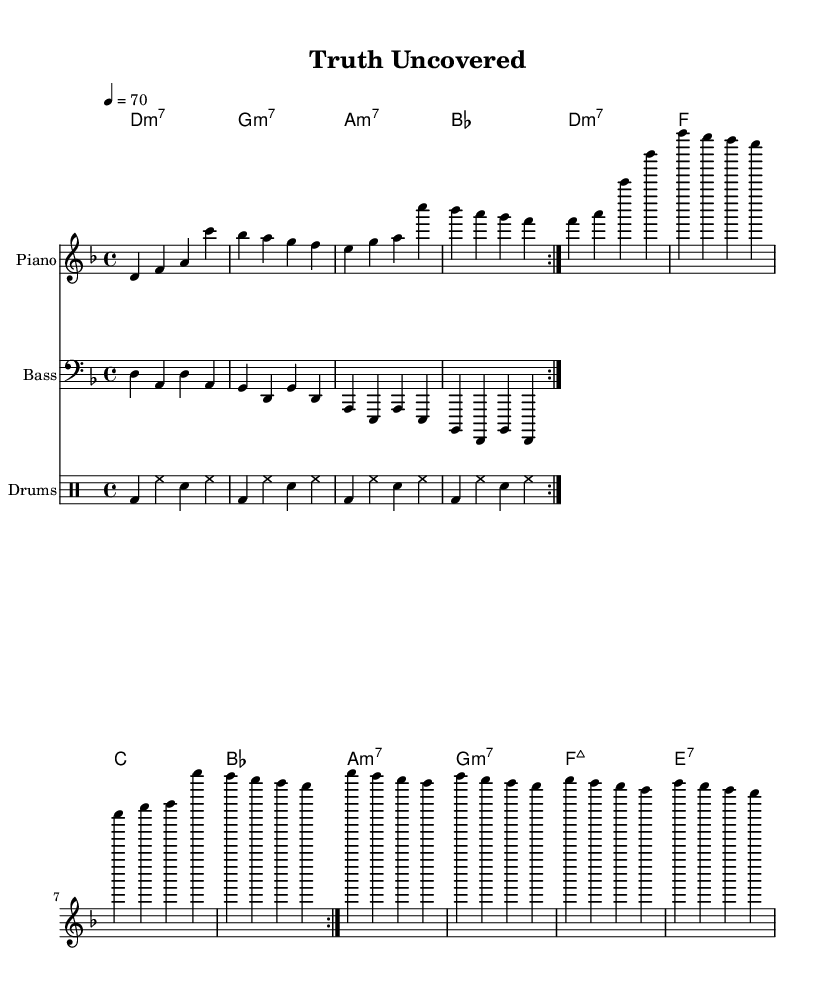What is the key signature of this music? The key signature is D minor, indicated by the presence of one flat (B flat) in the key signature area at the beginning of the score.
Answer: D minor What is the time signature of this music? The time signature is 4/4, which is shown at the beginning of the piece, indicating that there are four beats in each measure.
Answer: 4/4 What is the tempo marking for this piece? The tempo marking is 70 beats per minute, noted just above the staff, which indicates the speed of the music.
Answer: 70 How many measures are repeated in the melody? The melody has two measures repeated, as indicated by the "repeat volta 2" notation, indicating that the two measures should be played twice.
Answer: 2 What type of seventh chord appears in the chord progression? The progression includes minor seventh chords such as D minor 7, G minor 7, and A minor 7, all clearly notated in the chord names.
Answer: Minor seventh What is the dominant chord in the chord progression? In the context of D minor, the dominant chord (fifth chord) is A minor 7, which serves to create tension leading back to the tonic chord.
Answer: A minor 7 What rhythmic element is prominently featured in the drum part? The rhythmic element is the bass drum, which is consistently played on the first and third beats of each measure, providing a solid foundation for the groove.
Answer: Bass drum 